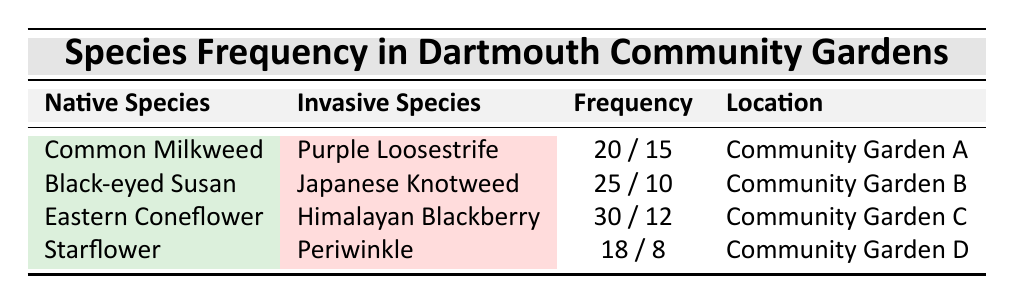What is the frequency of Common Milkweed in Community Garden A? The table indicates that the frequency of Common Milkweed, which is categorized as a native species, is 20 in Community Garden A.
Answer: 20 How many invasive species are listed in the table? The table lists four invasive species: Purple Loosestrife, Japanese Knotweed, Himalayan Blackberry, and Periwinkle. Therefore, the total count of invasive species is 4.
Answer: 4 Which community garden has the highest frequency of native species? By reviewing the table, Eastern Coneflower in Community Garden C has the highest frequency at 30, making it the highest frequency of native species listed.
Answer: Community Garden C What is the total frequency of native species in all the community gardens? We sum the frequencies of all native species from the table: 20 (Common Milkweed) + 25 (Black-eyed Susan) + 30 (Eastern Coneflower) + 18 (Starflower) = 93. Thus, the total frequency is 93.
Answer: 93 Is the frequency of Japanese Knotweed greater than that of Starflower? The frequency of Japanese Knotweed is 10, while the frequency of Starflower is 18. Since 10 is not greater than 18, the statement is false.
Answer: No Which invasive species has the lowest frequency in the gardens? The frequencies of invasive species are: Purple Loosestrife (15), Japanese Knotweed (10), Himalayan Blackberry (12), and Periwinkle (8). Periwinkle has the lowest frequency at 8.
Answer: Periwinkle What is the difference in frequency between the highest native species and the highest invasive species? The highest frequency of a native species is 30 (Eastern Coneflower) and the highest frequency of an invasive species is 15 (Purple Loosestrife). The difference is 30 - 15 = 15.
Answer: 15 In which location can you find the Black-eyed Susan? According to the table, Black-eyed Susan is found in Community Garden B.
Answer: Community Garden B How many total species are recorded in Community Garden D? Community Garden D has two species listed: Periwinkle (invasive) and Starflower (native). Therefore, the total species count is 2.
Answer: 2 